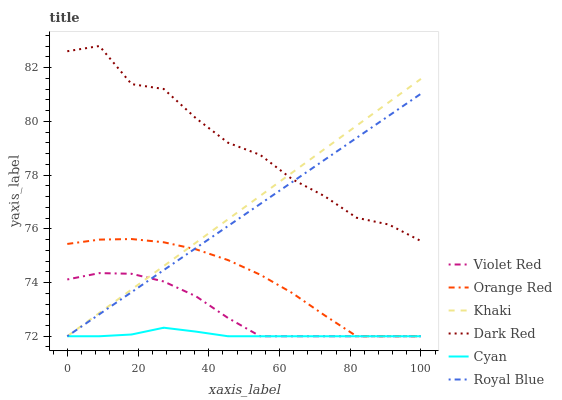Does Cyan have the minimum area under the curve?
Answer yes or no. Yes. Does Dark Red have the maximum area under the curve?
Answer yes or no. Yes. Does Khaki have the minimum area under the curve?
Answer yes or no. No. Does Khaki have the maximum area under the curve?
Answer yes or no. No. Is Khaki the smoothest?
Answer yes or no. Yes. Is Dark Red the roughest?
Answer yes or no. Yes. Is Dark Red the smoothest?
Answer yes or no. No. Is Khaki the roughest?
Answer yes or no. No. Does Violet Red have the lowest value?
Answer yes or no. Yes. Does Dark Red have the lowest value?
Answer yes or no. No. Does Dark Red have the highest value?
Answer yes or no. Yes. Does Khaki have the highest value?
Answer yes or no. No. Is Cyan less than Dark Red?
Answer yes or no. Yes. Is Dark Red greater than Cyan?
Answer yes or no. Yes. Does Khaki intersect Orange Red?
Answer yes or no. Yes. Is Khaki less than Orange Red?
Answer yes or no. No. Is Khaki greater than Orange Red?
Answer yes or no. No. Does Cyan intersect Dark Red?
Answer yes or no. No. 